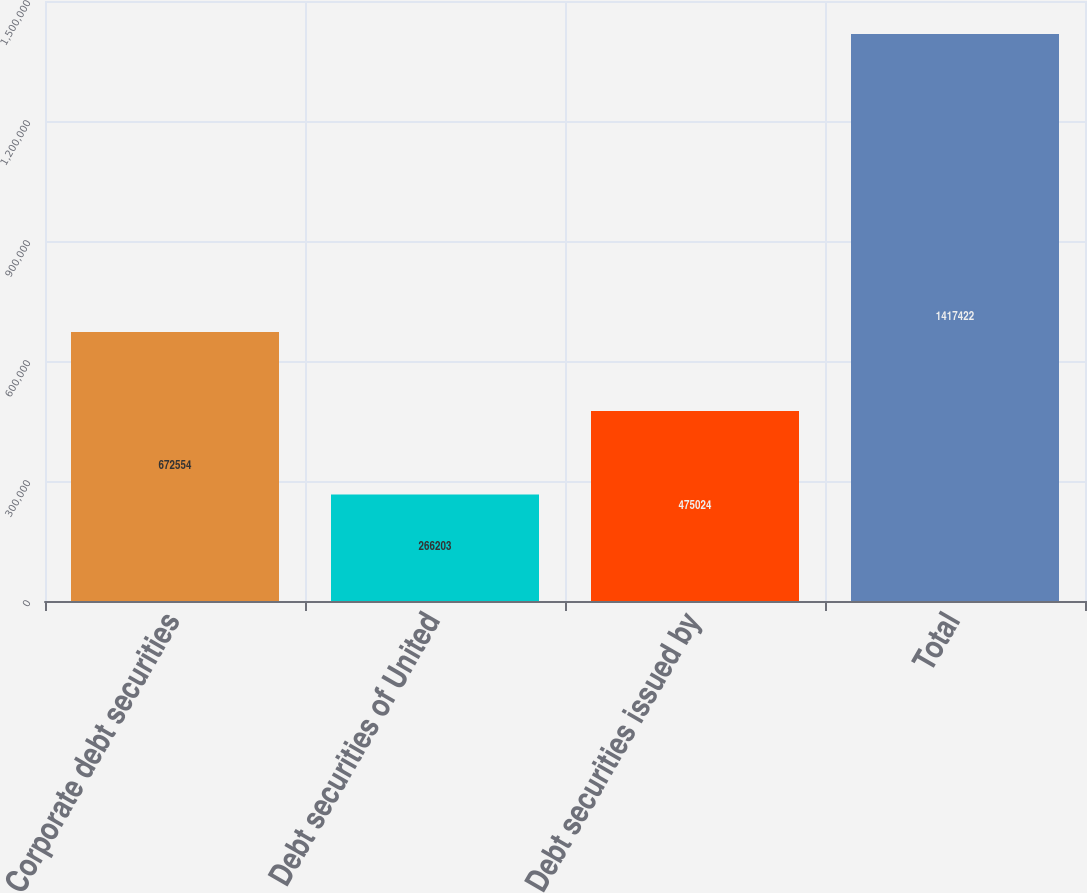<chart> <loc_0><loc_0><loc_500><loc_500><bar_chart><fcel>Corporate debt securities<fcel>Debt securities of United<fcel>Debt securities issued by<fcel>Total<nl><fcel>672554<fcel>266203<fcel>475024<fcel>1.41742e+06<nl></chart> 